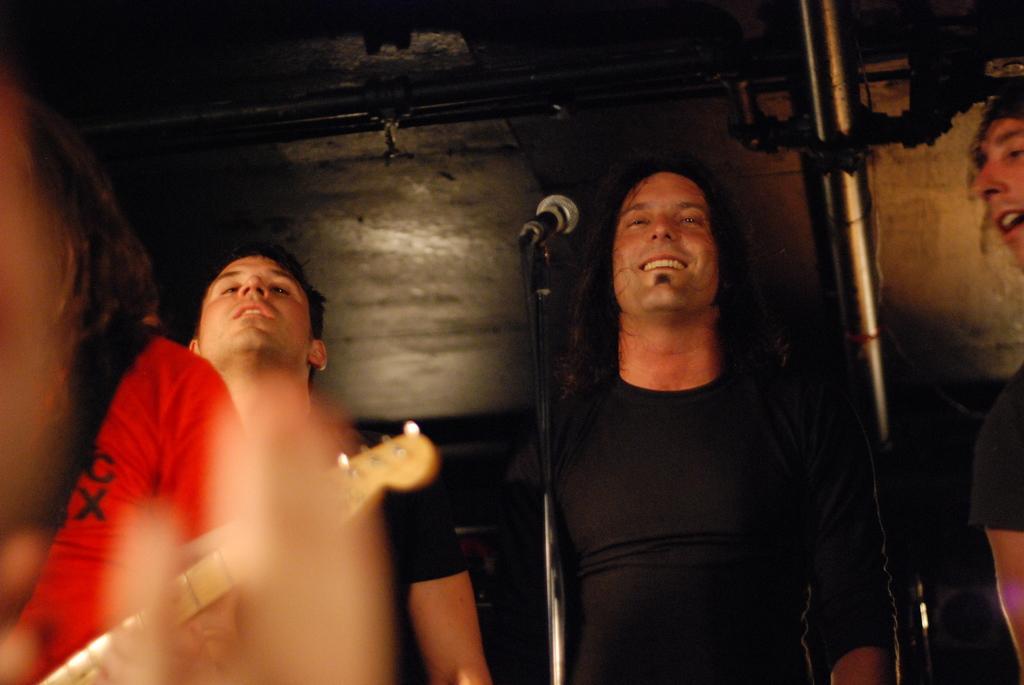Could you give a brief overview of what you see in this image? In this image we can see people. in the center there is a mic placed on the stand. on the left there is a person holding a guitar. in the background there is a wall and we can see a pipe. 